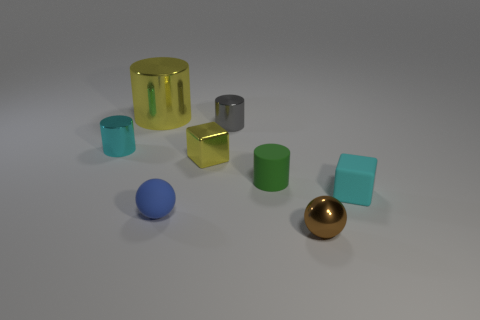Is there a tiny blue thing of the same shape as the cyan metallic object?
Your answer should be compact. No. What is the shape of the small thing that is on the left side of the small yellow object and on the right side of the large yellow metallic object?
Give a very brief answer. Sphere. Are the small yellow block and the small block to the right of the tiny shiny cube made of the same material?
Your answer should be very brief. No. There is a small brown thing; are there any matte balls in front of it?
Provide a succinct answer. No. How many things are either tiny cylinders or small cyan matte objects behind the rubber ball?
Your answer should be compact. 4. What is the color of the tiny matte object to the right of the metal thing that is in front of the tiny metal cube?
Provide a succinct answer. Cyan. How many other things are there of the same material as the small gray cylinder?
Provide a succinct answer. 4. How many matte things are purple things or blocks?
Make the answer very short. 1. What color is the other thing that is the same shape as the tiny blue object?
Your answer should be very brief. Brown. How many objects are either blocks or big red shiny things?
Keep it short and to the point. 2. 